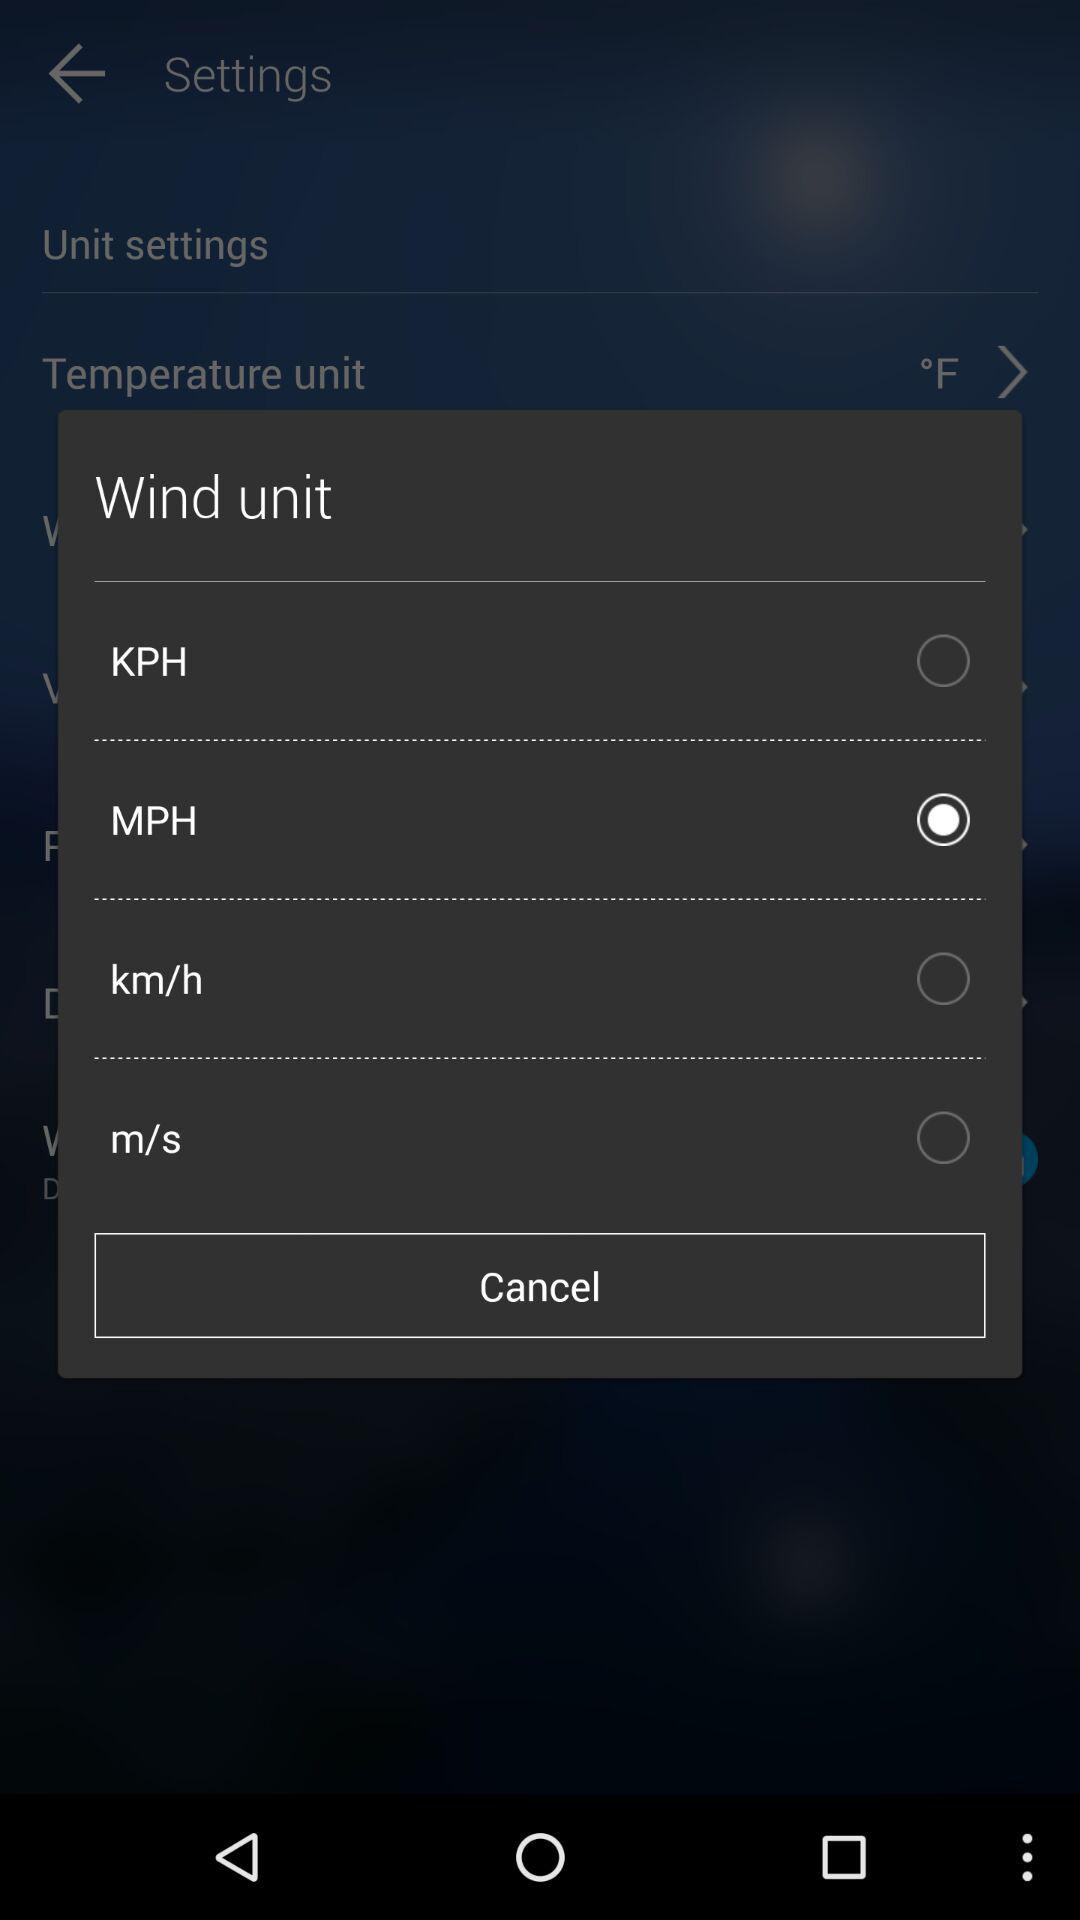What is the selected unit of wind? The selected unit of wind is MPH. 